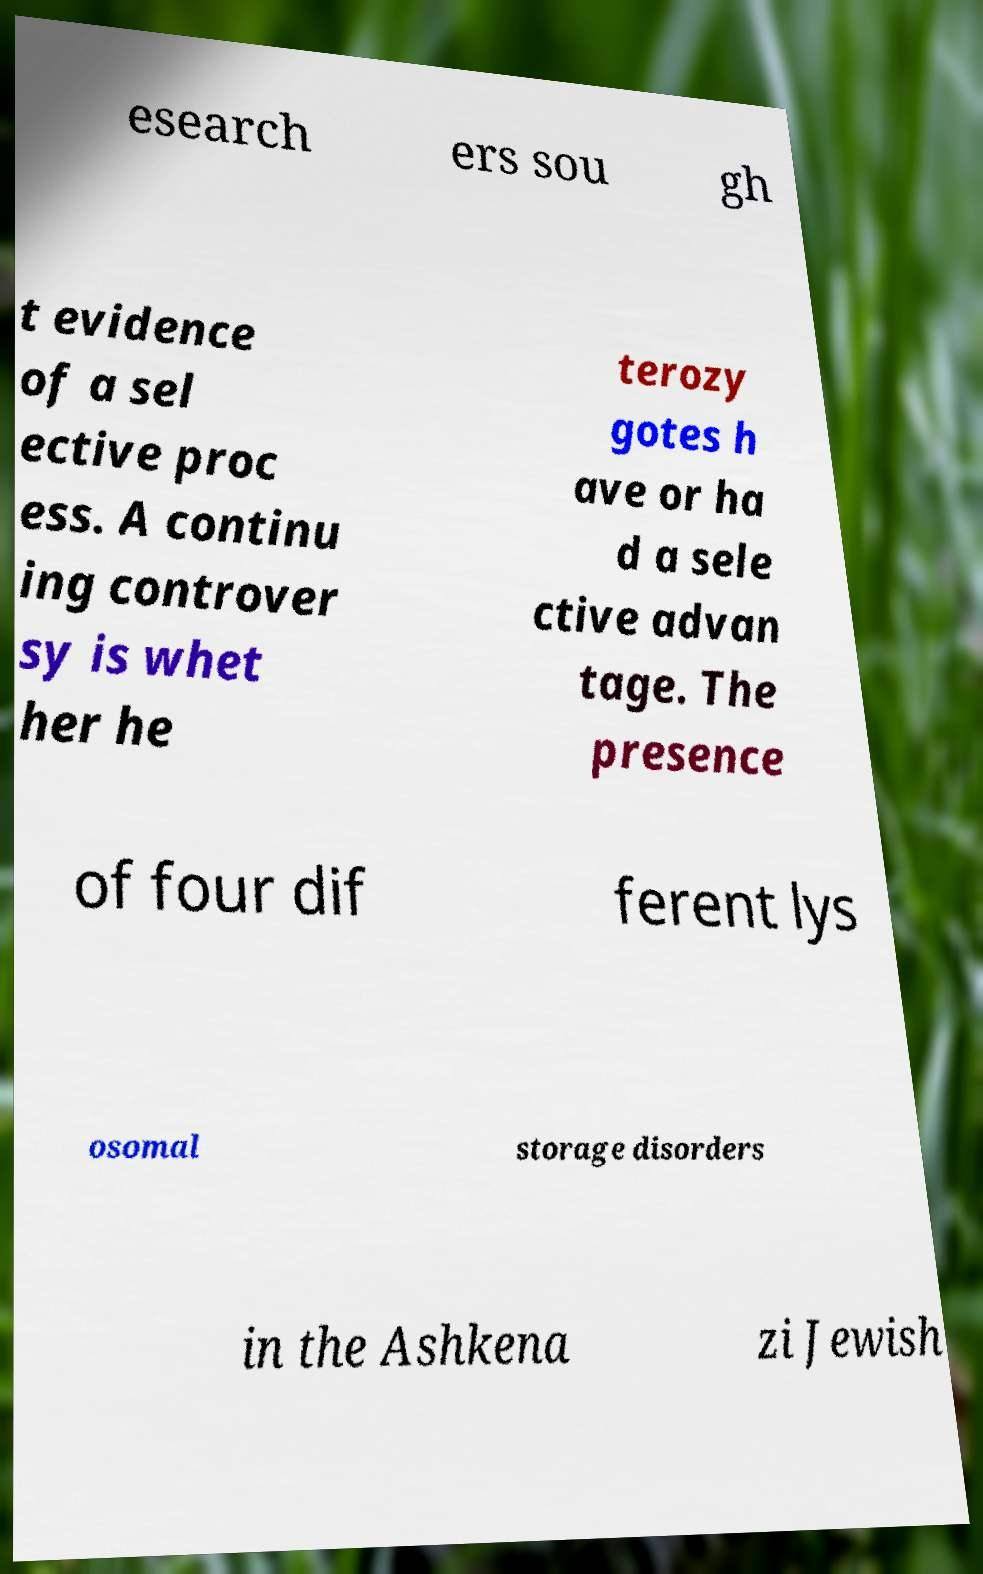Can you accurately transcribe the text from the provided image for me? esearch ers sou gh t evidence of a sel ective proc ess. A continu ing controver sy is whet her he terozy gotes h ave or ha d a sele ctive advan tage. The presence of four dif ferent lys osomal storage disorders in the Ashkena zi Jewish 